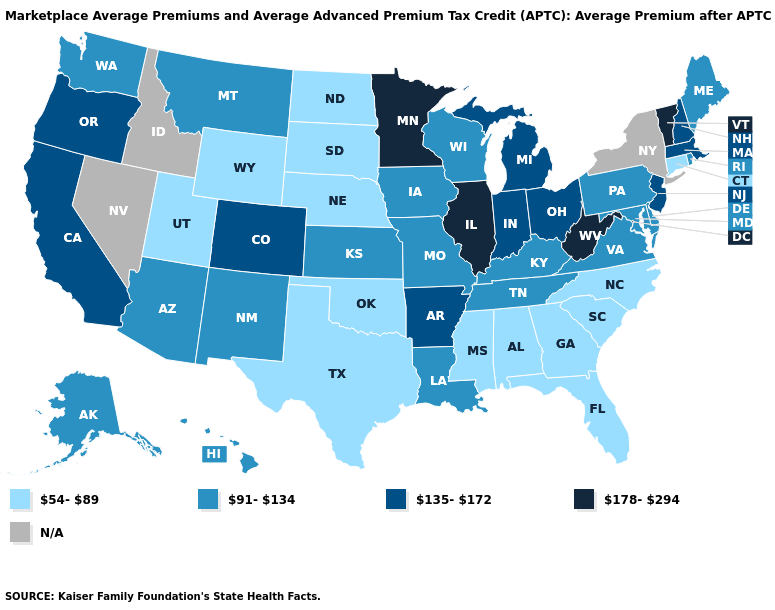What is the value of North Dakota?
Write a very short answer. 54-89. Which states hav the highest value in the MidWest?
Be succinct. Illinois, Minnesota. Does Wyoming have the lowest value in the West?
Concise answer only. Yes. Name the states that have a value in the range 178-294?
Be succinct. Illinois, Minnesota, Vermont, West Virginia. Which states hav the highest value in the West?
Give a very brief answer. California, Colorado, Oregon. Is the legend a continuous bar?
Give a very brief answer. No. Name the states that have a value in the range 54-89?
Be succinct. Alabama, Connecticut, Florida, Georgia, Mississippi, Nebraska, North Carolina, North Dakota, Oklahoma, South Carolina, South Dakota, Texas, Utah, Wyoming. Name the states that have a value in the range 54-89?
Quick response, please. Alabama, Connecticut, Florida, Georgia, Mississippi, Nebraska, North Carolina, North Dakota, Oklahoma, South Carolina, South Dakota, Texas, Utah, Wyoming. What is the highest value in the USA?
Give a very brief answer. 178-294. Name the states that have a value in the range N/A?
Write a very short answer. Idaho, Nevada, New York. What is the value of South Dakota?
Concise answer only. 54-89. What is the value of North Dakota?
Be succinct. 54-89. What is the highest value in the USA?
Write a very short answer. 178-294. 